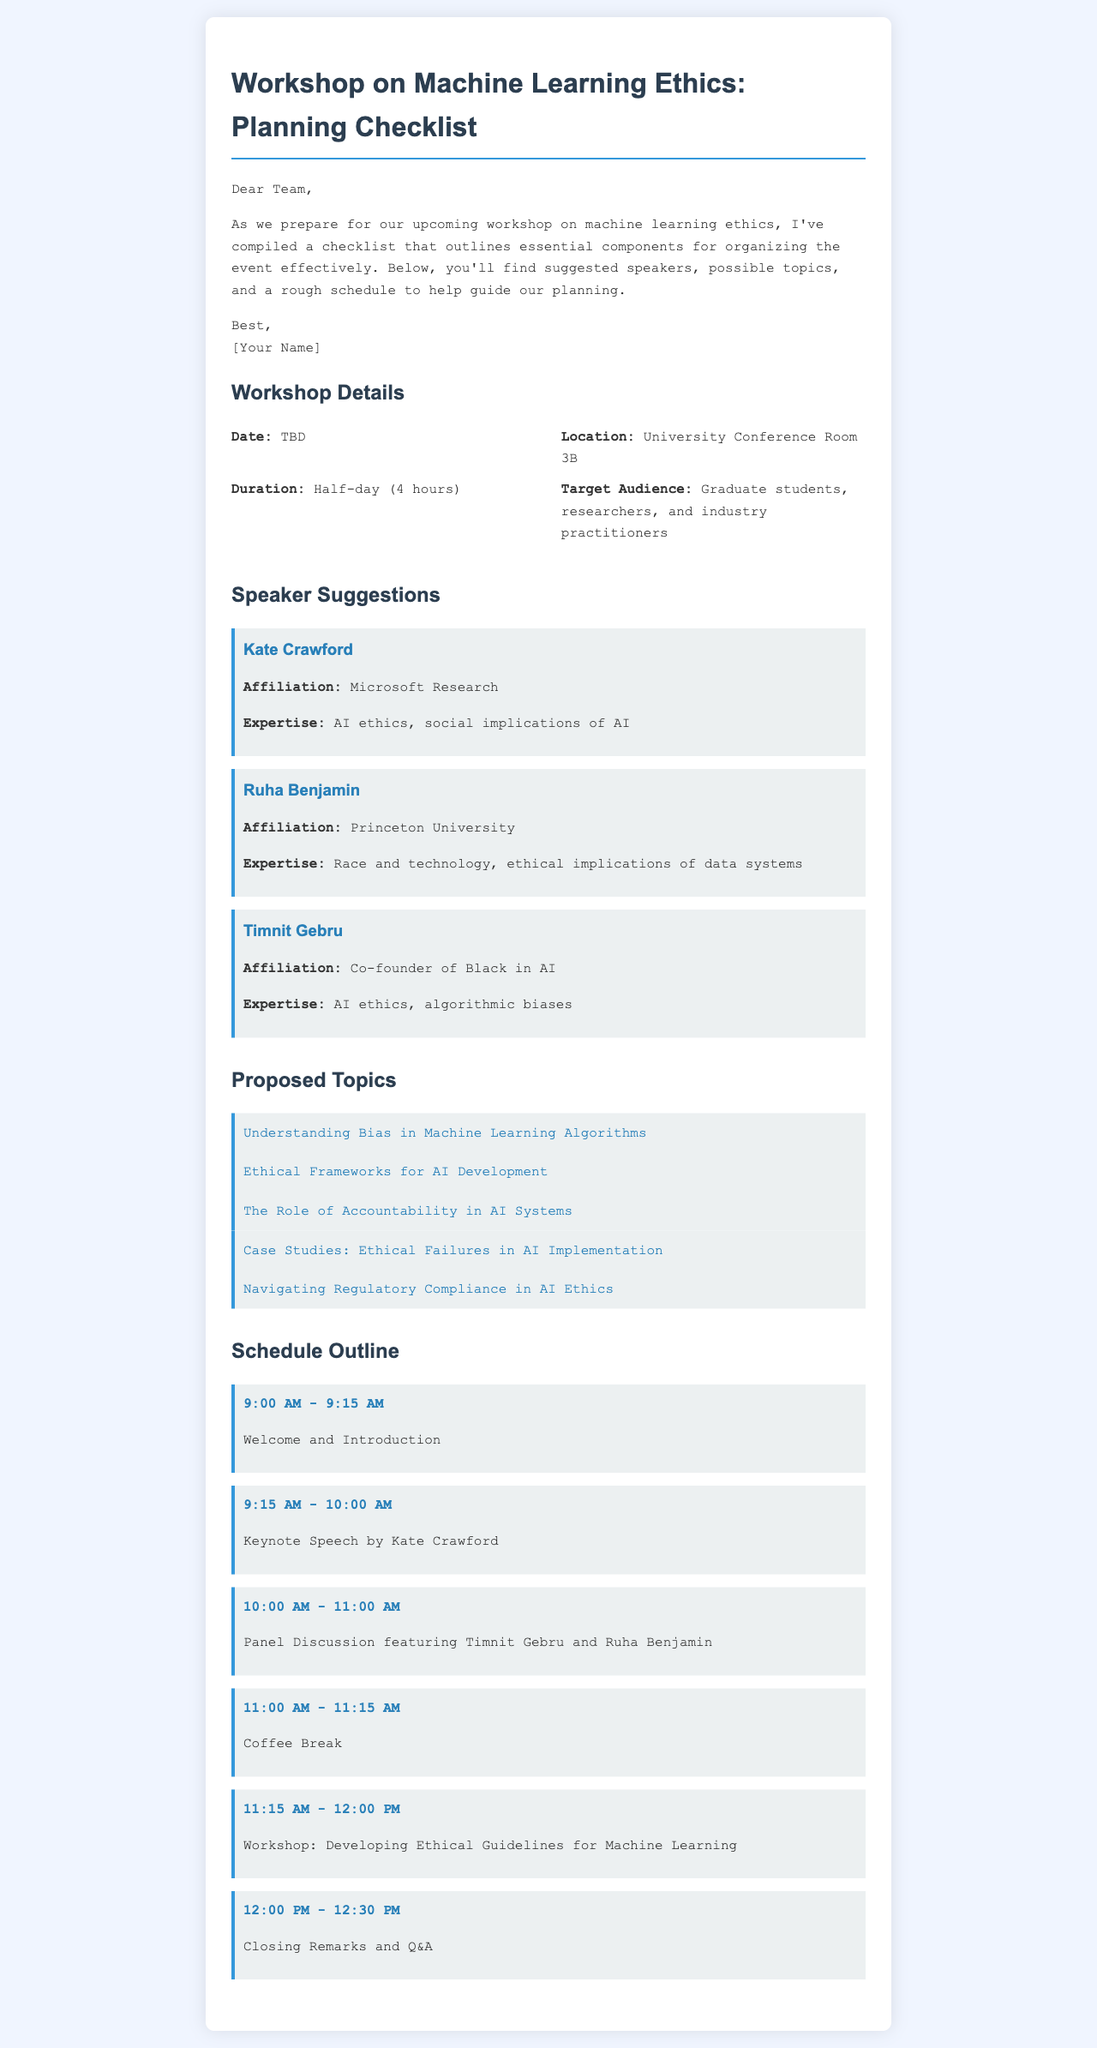What is the location of the workshop? The location of the workshop is specified as University Conference Room 3B in the document.
Answer: University Conference Room 3B What is the duration of the workshop? The duration is stated as half-day (4 hours) in the document.
Answer: Half-day (4 hours) Who is the keynote speaker? The document identifies Kate Crawford as the keynote speaker for the event.
Answer: Kate Crawford What is one of the proposed topics? The document lists several proposed topics; one example is "Understanding Bias in Machine Learning Algorithms."
Answer: Understanding Bias in Machine Learning Algorithms How long is the coffee break scheduled for? The document specifies the coffee break duration between 11:00 AM and 11:15 AM, which implies a 15-minute break.
Answer: 15 minutes What type of audience is targeted for the workshop? The target audience outlined in the document includes graduate students, researchers, and industry practitioners.
Answer: Graduate students, researchers, and industry practitioners What is planned after the welcome and introduction? According to the schedule outline, the keynote speech by Kate Crawford is planned immediately after the welcome and introduction.
Answer: Keynote Speech by Kate Crawford Who will participate in the panel discussion? The panel discussion will include Timnit Gebru and Ruha Benjamin as mentioned in the document.
Answer: Timnit Gebru and Ruha Benjamin What section follows the schedule outline? The section that follows the schedule outline in the document is about the closing remarks and Q&A session.
Answer: Closing Remarks and Q&A 